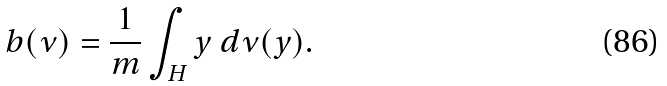<formula> <loc_0><loc_0><loc_500><loc_500>b ( \nu ) = \frac { 1 } { m } \int _ { H } y \ d \nu ( y ) .</formula> 